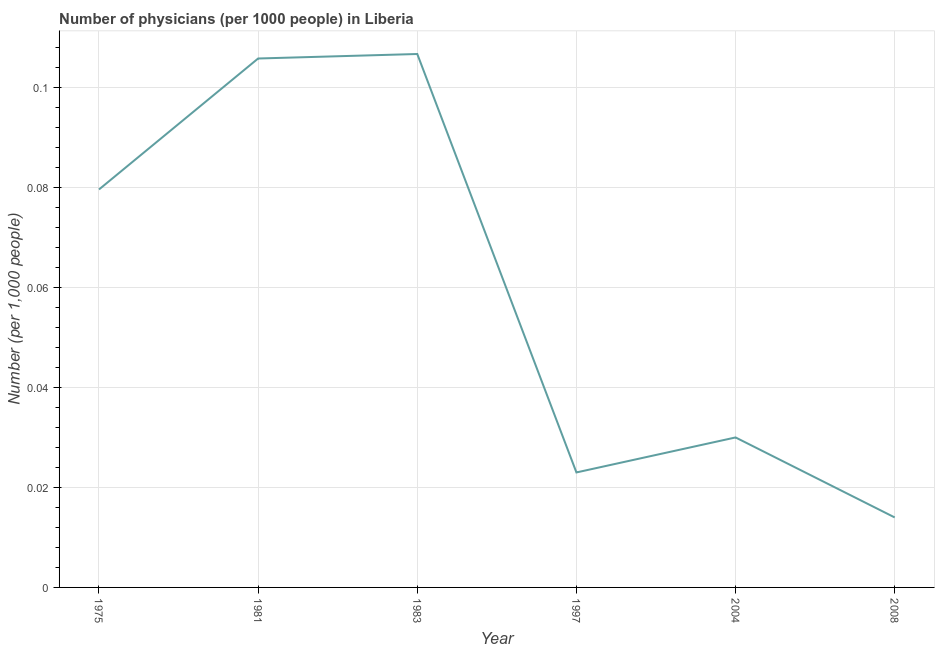What is the number of physicians in 1981?
Ensure brevity in your answer.  0.11. Across all years, what is the maximum number of physicians?
Keep it short and to the point. 0.11. Across all years, what is the minimum number of physicians?
Your answer should be compact. 0.01. In which year was the number of physicians maximum?
Your response must be concise. 1983. What is the sum of the number of physicians?
Your response must be concise. 0.36. What is the difference between the number of physicians in 1975 and 1997?
Keep it short and to the point. 0.06. What is the average number of physicians per year?
Provide a short and direct response. 0.06. What is the median number of physicians?
Make the answer very short. 0.05. In how many years, is the number of physicians greater than 0.06 ?
Ensure brevity in your answer.  3. Do a majority of the years between 1975 and 2004 (inclusive) have number of physicians greater than 0.06 ?
Ensure brevity in your answer.  Yes. What is the ratio of the number of physicians in 1975 to that in 2004?
Provide a succinct answer. 2.65. Is the number of physicians in 1981 less than that in 1983?
Make the answer very short. Yes. Is the difference between the number of physicians in 1975 and 2008 greater than the difference between any two years?
Offer a terse response. No. What is the difference between the highest and the second highest number of physicians?
Offer a very short reply. 0. What is the difference between the highest and the lowest number of physicians?
Your response must be concise. 0.09. What is the difference between two consecutive major ticks on the Y-axis?
Make the answer very short. 0.02. Does the graph contain any zero values?
Provide a succinct answer. No. What is the title of the graph?
Ensure brevity in your answer.  Number of physicians (per 1000 people) in Liberia. What is the label or title of the Y-axis?
Keep it short and to the point. Number (per 1,0 people). What is the Number (per 1,000 people) in 1975?
Ensure brevity in your answer.  0.08. What is the Number (per 1,000 people) of 1981?
Offer a terse response. 0.11. What is the Number (per 1,000 people) of 1983?
Your answer should be very brief. 0.11. What is the Number (per 1,000 people) of 1997?
Offer a very short reply. 0.02. What is the Number (per 1,000 people) in 2008?
Keep it short and to the point. 0.01. What is the difference between the Number (per 1,000 people) in 1975 and 1981?
Ensure brevity in your answer.  -0.03. What is the difference between the Number (per 1,000 people) in 1975 and 1983?
Your response must be concise. -0.03. What is the difference between the Number (per 1,000 people) in 1975 and 1997?
Offer a terse response. 0.06. What is the difference between the Number (per 1,000 people) in 1975 and 2004?
Your answer should be very brief. 0.05. What is the difference between the Number (per 1,000 people) in 1975 and 2008?
Provide a short and direct response. 0.07. What is the difference between the Number (per 1,000 people) in 1981 and 1983?
Provide a succinct answer. -0. What is the difference between the Number (per 1,000 people) in 1981 and 1997?
Offer a terse response. 0.08. What is the difference between the Number (per 1,000 people) in 1981 and 2004?
Make the answer very short. 0.08. What is the difference between the Number (per 1,000 people) in 1981 and 2008?
Ensure brevity in your answer.  0.09. What is the difference between the Number (per 1,000 people) in 1983 and 1997?
Give a very brief answer. 0.08. What is the difference between the Number (per 1,000 people) in 1983 and 2004?
Provide a short and direct response. 0.08. What is the difference between the Number (per 1,000 people) in 1983 and 2008?
Your response must be concise. 0.09. What is the difference between the Number (per 1,000 people) in 1997 and 2004?
Ensure brevity in your answer.  -0.01. What is the difference between the Number (per 1,000 people) in 1997 and 2008?
Your answer should be compact. 0.01. What is the difference between the Number (per 1,000 people) in 2004 and 2008?
Make the answer very short. 0.02. What is the ratio of the Number (per 1,000 people) in 1975 to that in 1981?
Offer a very short reply. 0.75. What is the ratio of the Number (per 1,000 people) in 1975 to that in 1983?
Give a very brief answer. 0.75. What is the ratio of the Number (per 1,000 people) in 1975 to that in 1997?
Keep it short and to the point. 3.46. What is the ratio of the Number (per 1,000 people) in 1975 to that in 2004?
Keep it short and to the point. 2.65. What is the ratio of the Number (per 1,000 people) in 1975 to that in 2008?
Ensure brevity in your answer.  5.69. What is the ratio of the Number (per 1,000 people) in 1981 to that in 1983?
Give a very brief answer. 0.99. What is the ratio of the Number (per 1,000 people) in 1981 to that in 1997?
Offer a terse response. 4.6. What is the ratio of the Number (per 1,000 people) in 1981 to that in 2004?
Your answer should be compact. 3.53. What is the ratio of the Number (per 1,000 people) in 1981 to that in 2008?
Your answer should be very brief. 7.56. What is the ratio of the Number (per 1,000 people) in 1983 to that in 1997?
Your answer should be compact. 4.64. What is the ratio of the Number (per 1,000 people) in 1983 to that in 2004?
Offer a terse response. 3.56. What is the ratio of the Number (per 1,000 people) in 1983 to that in 2008?
Provide a succinct answer. 7.62. What is the ratio of the Number (per 1,000 people) in 1997 to that in 2004?
Your answer should be very brief. 0.77. What is the ratio of the Number (per 1,000 people) in 1997 to that in 2008?
Provide a succinct answer. 1.64. What is the ratio of the Number (per 1,000 people) in 2004 to that in 2008?
Your response must be concise. 2.14. 